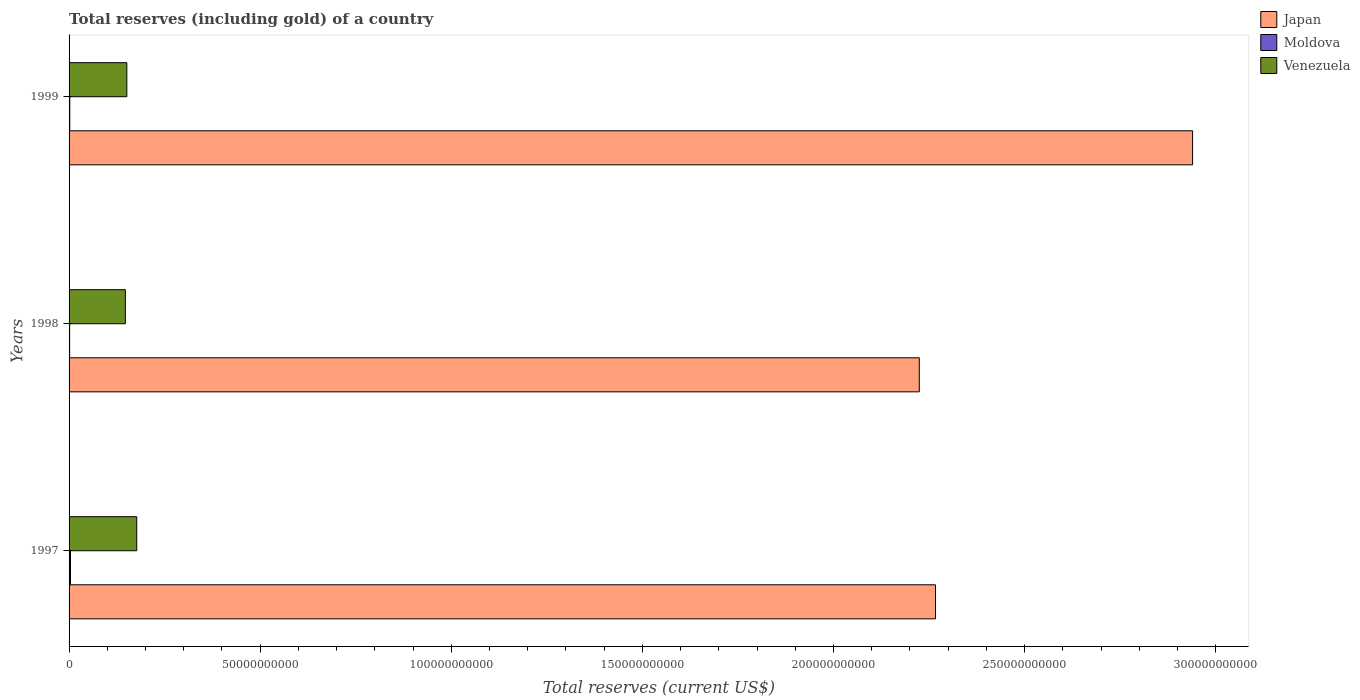How many groups of bars are there?
Provide a short and direct response. 3. Are the number of bars per tick equal to the number of legend labels?
Offer a very short reply. Yes. Are the number of bars on each tick of the Y-axis equal?
Provide a succinct answer. Yes. How many bars are there on the 2nd tick from the top?
Keep it short and to the point. 3. What is the label of the 2nd group of bars from the top?
Offer a very short reply. 1998. In how many cases, is the number of bars for a given year not equal to the number of legend labels?
Make the answer very short. 0. What is the total reserves (including gold) in Venezuela in 1999?
Make the answer very short. 1.51e+1. Across all years, what is the maximum total reserves (including gold) in Japan?
Give a very brief answer. 2.94e+11. Across all years, what is the minimum total reserves (including gold) in Moldova?
Your answer should be very brief. 1.44e+08. What is the total total reserves (including gold) in Venezuela in the graph?
Provide a short and direct response. 4.75e+1. What is the difference between the total reserves (including gold) in Venezuela in 1997 and that in 1998?
Your answer should be compact. 2.97e+09. What is the difference between the total reserves (including gold) in Venezuela in 1997 and the total reserves (including gold) in Japan in 1999?
Offer a terse response. -2.76e+11. What is the average total reserves (including gold) in Japan per year?
Your answer should be compact. 2.48e+11. In the year 1998, what is the difference between the total reserves (including gold) in Japan and total reserves (including gold) in Moldova?
Provide a succinct answer. 2.22e+11. In how many years, is the total reserves (including gold) in Venezuela greater than 220000000000 US$?
Keep it short and to the point. 0. What is the ratio of the total reserves (including gold) in Japan in 1997 to that in 1999?
Keep it short and to the point. 0.77. What is the difference between the highest and the second highest total reserves (including gold) in Moldova?
Offer a very short reply. 1.80e+08. What is the difference between the highest and the lowest total reserves (including gold) in Moldova?
Your answer should be compact. 2.22e+08. In how many years, is the total reserves (including gold) in Japan greater than the average total reserves (including gold) in Japan taken over all years?
Give a very brief answer. 1. What does the 2nd bar from the top in 1998 represents?
Give a very brief answer. Moldova. What does the 2nd bar from the bottom in 1998 represents?
Offer a very short reply. Moldova. How many bars are there?
Make the answer very short. 9. What is the difference between two consecutive major ticks on the X-axis?
Your answer should be very brief. 5.00e+1. Does the graph contain grids?
Offer a terse response. No. What is the title of the graph?
Offer a terse response. Total reserves (including gold) of a country. What is the label or title of the X-axis?
Provide a succinct answer. Total reserves (current US$). What is the Total reserves (current US$) of Japan in 1997?
Your answer should be compact. 2.27e+11. What is the Total reserves (current US$) in Moldova in 1997?
Keep it short and to the point. 3.66e+08. What is the Total reserves (current US$) of Venezuela in 1997?
Your answer should be compact. 1.77e+1. What is the Total reserves (current US$) of Japan in 1998?
Offer a very short reply. 2.22e+11. What is the Total reserves (current US$) of Moldova in 1998?
Your answer should be very brief. 1.44e+08. What is the Total reserves (current US$) of Venezuela in 1998?
Your answer should be compact. 1.47e+1. What is the Total reserves (current US$) in Japan in 1999?
Provide a succinct answer. 2.94e+11. What is the Total reserves (current US$) of Moldova in 1999?
Offer a terse response. 1.86e+08. What is the Total reserves (current US$) in Venezuela in 1999?
Make the answer very short. 1.51e+1. Across all years, what is the maximum Total reserves (current US$) of Japan?
Offer a terse response. 2.94e+11. Across all years, what is the maximum Total reserves (current US$) in Moldova?
Keep it short and to the point. 3.66e+08. Across all years, what is the maximum Total reserves (current US$) of Venezuela?
Your answer should be compact. 1.77e+1. Across all years, what is the minimum Total reserves (current US$) of Japan?
Make the answer very short. 2.22e+11. Across all years, what is the minimum Total reserves (current US$) of Moldova?
Offer a very short reply. 1.44e+08. Across all years, what is the minimum Total reserves (current US$) in Venezuela?
Provide a succinct answer. 1.47e+1. What is the total Total reserves (current US$) in Japan in the graph?
Provide a succinct answer. 7.43e+11. What is the total Total reserves (current US$) in Moldova in the graph?
Your answer should be compact. 6.95e+08. What is the total Total reserves (current US$) of Venezuela in the graph?
Your response must be concise. 4.75e+1. What is the difference between the Total reserves (current US$) in Japan in 1997 and that in 1998?
Provide a short and direct response. 4.24e+09. What is the difference between the Total reserves (current US$) of Moldova in 1997 and that in 1998?
Provide a short and direct response. 2.22e+08. What is the difference between the Total reserves (current US$) of Venezuela in 1997 and that in 1998?
Provide a succinct answer. 2.97e+09. What is the difference between the Total reserves (current US$) of Japan in 1997 and that in 1999?
Give a very brief answer. -6.73e+1. What is the difference between the Total reserves (current US$) in Moldova in 1997 and that in 1999?
Make the answer very short. 1.80e+08. What is the difference between the Total reserves (current US$) of Venezuela in 1997 and that in 1999?
Provide a short and direct response. 2.59e+09. What is the difference between the Total reserves (current US$) of Japan in 1998 and that in 1999?
Your response must be concise. -7.15e+1. What is the difference between the Total reserves (current US$) of Moldova in 1998 and that in 1999?
Offer a terse response. -4.21e+07. What is the difference between the Total reserves (current US$) of Venezuela in 1998 and that in 1999?
Give a very brief answer. -3.81e+08. What is the difference between the Total reserves (current US$) in Japan in 1997 and the Total reserves (current US$) in Moldova in 1998?
Provide a succinct answer. 2.27e+11. What is the difference between the Total reserves (current US$) of Japan in 1997 and the Total reserves (current US$) of Venezuela in 1998?
Give a very brief answer. 2.12e+11. What is the difference between the Total reserves (current US$) in Moldova in 1997 and the Total reserves (current US$) in Venezuela in 1998?
Your response must be concise. -1.44e+1. What is the difference between the Total reserves (current US$) in Japan in 1997 and the Total reserves (current US$) in Moldova in 1999?
Offer a very short reply. 2.26e+11. What is the difference between the Total reserves (current US$) in Japan in 1997 and the Total reserves (current US$) in Venezuela in 1999?
Provide a short and direct response. 2.12e+11. What is the difference between the Total reserves (current US$) in Moldova in 1997 and the Total reserves (current US$) in Venezuela in 1999?
Make the answer very short. -1.47e+1. What is the difference between the Total reserves (current US$) in Japan in 1998 and the Total reserves (current US$) in Moldova in 1999?
Your answer should be very brief. 2.22e+11. What is the difference between the Total reserves (current US$) of Japan in 1998 and the Total reserves (current US$) of Venezuela in 1999?
Your answer should be compact. 2.07e+11. What is the difference between the Total reserves (current US$) in Moldova in 1998 and the Total reserves (current US$) in Venezuela in 1999?
Make the answer very short. -1.50e+1. What is the average Total reserves (current US$) in Japan per year?
Your answer should be compact. 2.48e+11. What is the average Total reserves (current US$) of Moldova per year?
Provide a succinct answer. 2.32e+08. What is the average Total reserves (current US$) of Venezuela per year?
Provide a short and direct response. 1.58e+1. In the year 1997, what is the difference between the Total reserves (current US$) of Japan and Total reserves (current US$) of Moldova?
Your response must be concise. 2.26e+11. In the year 1997, what is the difference between the Total reserves (current US$) in Japan and Total reserves (current US$) in Venezuela?
Keep it short and to the point. 2.09e+11. In the year 1997, what is the difference between the Total reserves (current US$) of Moldova and Total reserves (current US$) of Venezuela?
Offer a terse response. -1.73e+1. In the year 1998, what is the difference between the Total reserves (current US$) in Japan and Total reserves (current US$) in Moldova?
Keep it short and to the point. 2.22e+11. In the year 1998, what is the difference between the Total reserves (current US$) of Japan and Total reserves (current US$) of Venezuela?
Keep it short and to the point. 2.08e+11. In the year 1998, what is the difference between the Total reserves (current US$) of Moldova and Total reserves (current US$) of Venezuela?
Ensure brevity in your answer.  -1.46e+1. In the year 1999, what is the difference between the Total reserves (current US$) in Japan and Total reserves (current US$) in Moldova?
Provide a succinct answer. 2.94e+11. In the year 1999, what is the difference between the Total reserves (current US$) in Japan and Total reserves (current US$) in Venezuela?
Give a very brief answer. 2.79e+11. In the year 1999, what is the difference between the Total reserves (current US$) of Moldova and Total reserves (current US$) of Venezuela?
Make the answer very short. -1.49e+1. What is the ratio of the Total reserves (current US$) in Moldova in 1997 to that in 1998?
Your answer should be very brief. 2.55. What is the ratio of the Total reserves (current US$) of Venezuela in 1997 to that in 1998?
Offer a terse response. 1.2. What is the ratio of the Total reserves (current US$) in Japan in 1997 to that in 1999?
Keep it short and to the point. 0.77. What is the ratio of the Total reserves (current US$) in Moldova in 1997 to that in 1999?
Your answer should be compact. 1.97. What is the ratio of the Total reserves (current US$) in Venezuela in 1997 to that in 1999?
Ensure brevity in your answer.  1.17. What is the ratio of the Total reserves (current US$) of Japan in 1998 to that in 1999?
Offer a very short reply. 0.76. What is the ratio of the Total reserves (current US$) in Moldova in 1998 to that in 1999?
Offer a terse response. 0.77. What is the ratio of the Total reserves (current US$) of Venezuela in 1998 to that in 1999?
Keep it short and to the point. 0.97. What is the difference between the highest and the second highest Total reserves (current US$) of Japan?
Your answer should be compact. 6.73e+1. What is the difference between the highest and the second highest Total reserves (current US$) in Moldova?
Provide a succinct answer. 1.80e+08. What is the difference between the highest and the second highest Total reserves (current US$) in Venezuela?
Make the answer very short. 2.59e+09. What is the difference between the highest and the lowest Total reserves (current US$) in Japan?
Give a very brief answer. 7.15e+1. What is the difference between the highest and the lowest Total reserves (current US$) of Moldova?
Your answer should be very brief. 2.22e+08. What is the difference between the highest and the lowest Total reserves (current US$) in Venezuela?
Make the answer very short. 2.97e+09. 